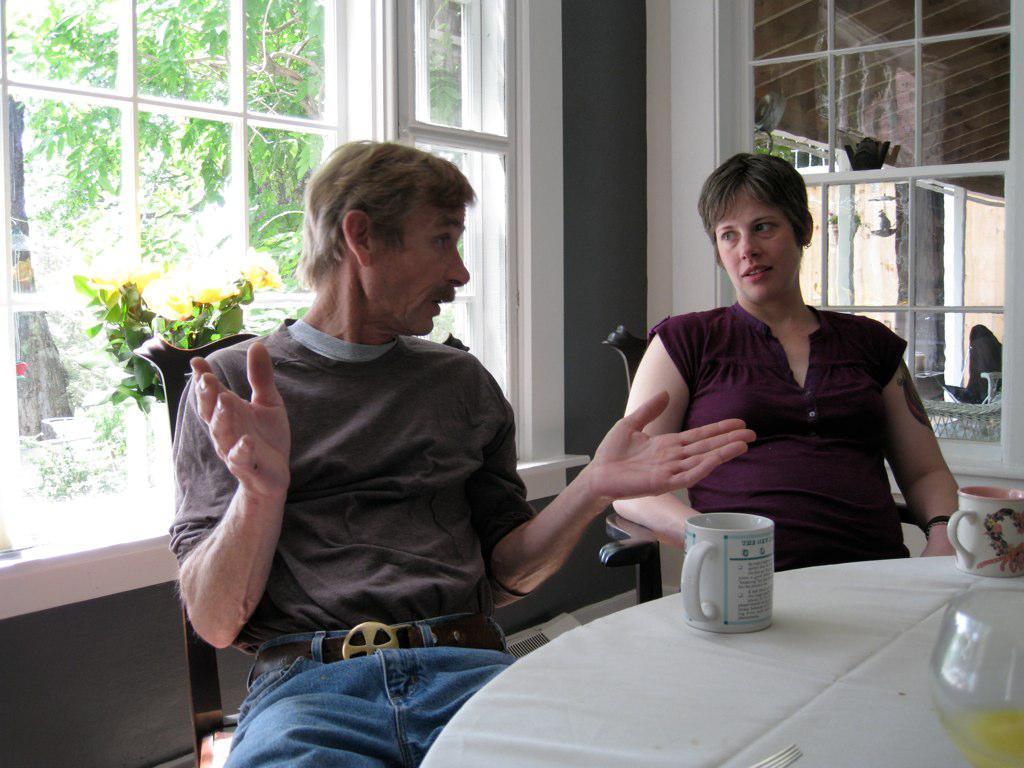Could you give a brief overview of what you see in this image? The photo is taken inside a room. There are two person one man and a woman. There is table in front of them. On the table there is mug there is a glass there is another mug. The man is wearing brown t shirt and blue jeans. The woman is wearing a maroon t shirt. the man is talking the woman. In the background there is a window ,a flower pot. Through the glasses of the window we can see trees. in the right top corner there is glass window. 